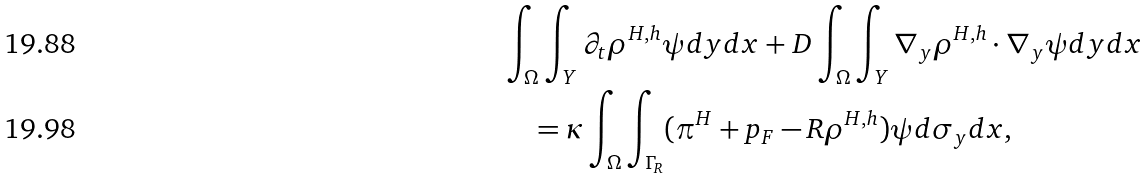Convert formula to latex. <formula><loc_0><loc_0><loc_500><loc_500>& \int _ { \Omega } \int _ { Y } \partial _ { t } \rho ^ { H , h } \psi d y d x + D \int _ { \Omega } \int _ { Y } \nabla _ { y } \rho ^ { H , h } \cdot \nabla _ { y } \psi d y d x \\ & \quad = \kappa \int _ { \Omega } \int _ { \Gamma _ { R } } ( \pi ^ { H } + p _ { F } - R \rho ^ { H , h } ) \psi d \sigma _ { y } d x ,</formula> 